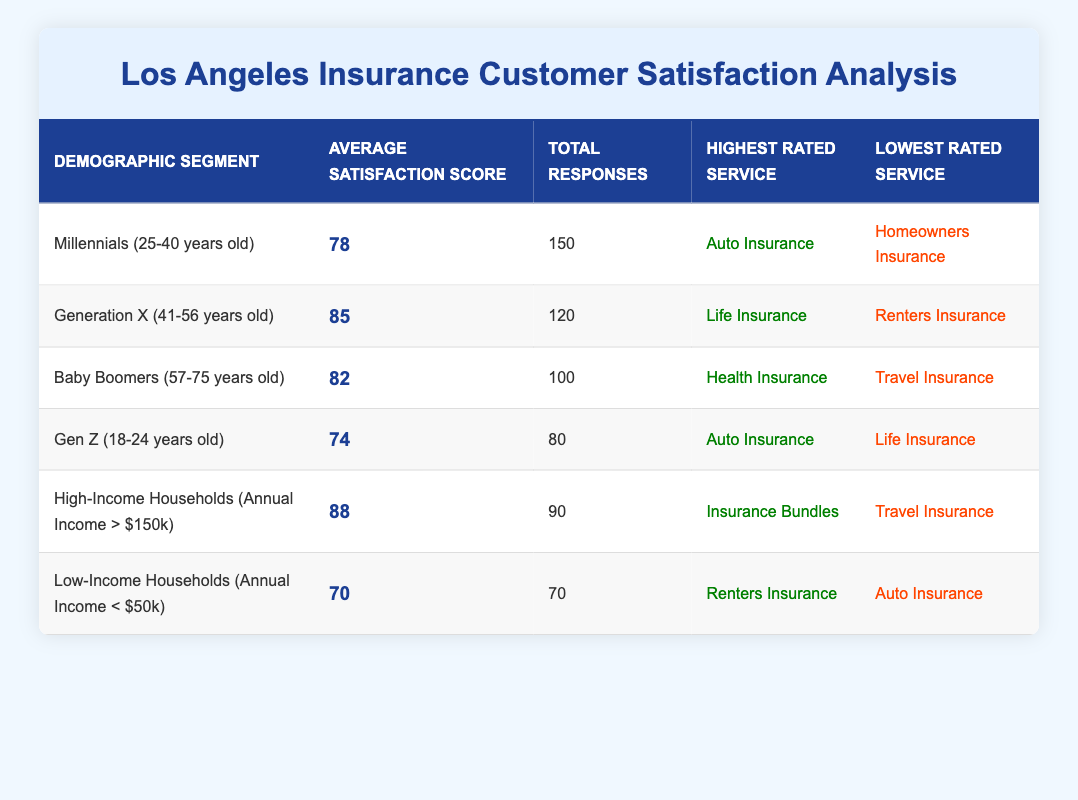What is the highest rated service by Millennials? The table shows that Millennials (25-40 years old) have rated Auto Insurance as their highest-rated service. This information is found directly in the respective row for this demographic.
Answer: Auto Insurance How many total responses were collected from Generation X? From the table, I can see that there were 120 total responses collected from the Generation X demographic (41-56 years old). This figure is listed in the corresponding row for Generation X.
Answer: 120 What is the average satisfaction score of Low-Income Households? The table states that Low-Income Households (Annual Income < $50k) have an average satisfaction score of 70. This data is specifically mentioned in the row for this demographic.
Answer: 70 Which demographic segment has the lowest average satisfaction score? To find the demographic segment with the lowest average satisfaction score, I compare the average scores of each segment: Millennials (78), Generation X (85), Baby Boomers (82), Gen Z (74), High-Income Households (88), and Low-Income Households (70). The lowest score is 70 for Low-Income Households, indicating they have the lowest satisfaction.
Answer: Low-Income Households What is the difference in average satisfaction scores between High-Income Households and Millennials? First, I need to find the average satisfaction scores for both segments. High-Income Households have a score of 88, while Millennials have a score of 78. The difference is calculated as 88 - 78 = 10.
Answer: 10 True or False: The average satisfaction score for Baby Boomers is higher than that for Gen Z. The table shows Baby Boomers (average score 82) and Gen Z (average score 74). Since 82 is greater than 74, the statement is true.
Answer: True What is the average satisfaction score among all demographic segments listed? To find the average across all segments, I add the satisfaction scores: 78 (Millennials) + 85 (Generation X) + 82 (Baby Boomers) + 74 (Gen Z) + 88 (High-Income Households) + 70 (Low-Income Households) = 477. Next, I divide this total by the number of segments (6), which gives me an average of 477 / 6 = 79.5.
Answer: 79.5 Which service was lowest rated by the Baby Boomers? According to the table, Baby Boomers rated Travel Insurance as their lowest-rated service. This information is specifically mentioned in the corresponding row for Baby Boomers.
Answer: Travel Insurance How many more responses did Millennials have compared to Low-Income Households? From the table, it's noted that Millennials had 150 responses, while Low-Income Households had 70. To find the difference, I calculate 150 - 70 = 80.
Answer: 80 